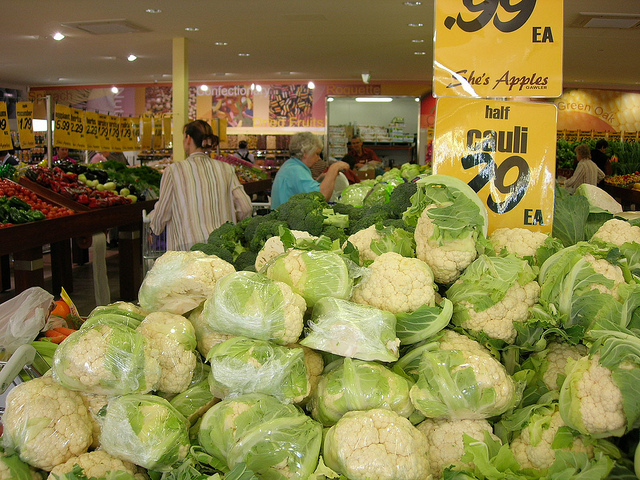How many people on any type of bike are facing the camera? 0 